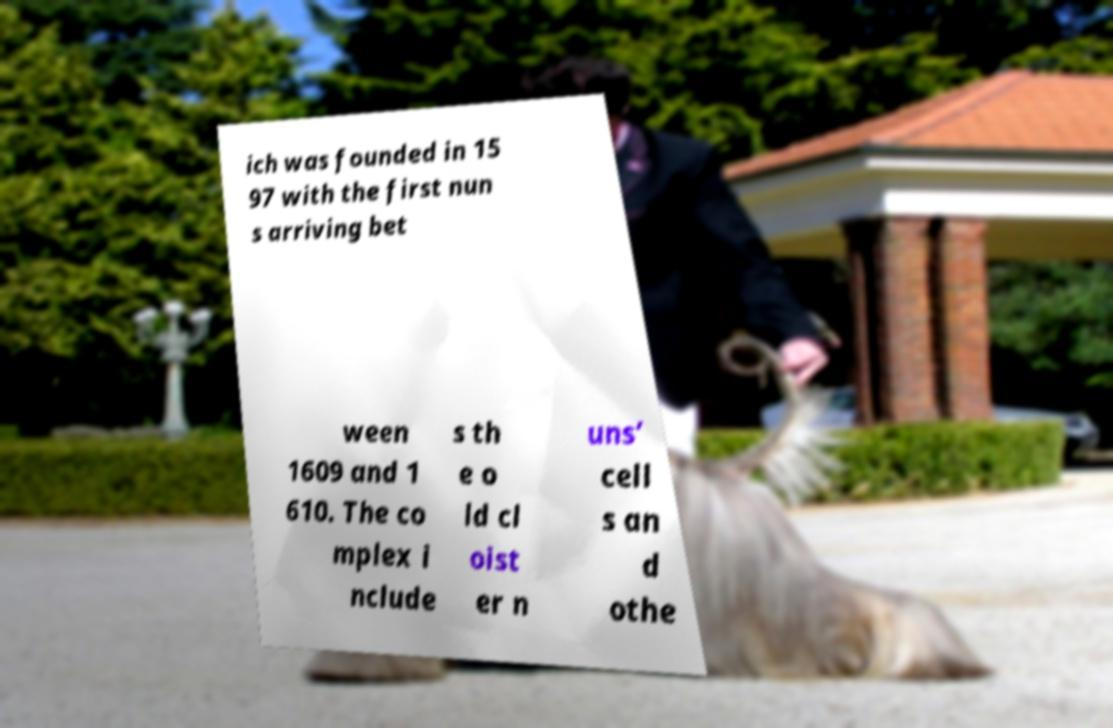Can you accurately transcribe the text from the provided image for me? ich was founded in 15 97 with the first nun s arriving bet ween 1609 and 1 610. The co mplex i nclude s th e o ld cl oist er n uns’ cell s an d othe 